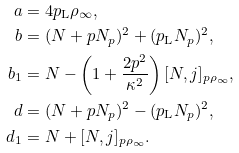Convert formula to latex. <formula><loc_0><loc_0><loc_500><loc_500>a & = 4 p _ { \text {L} } \rho _ { \infty } , \\ b & = ( N + p N _ { p } ) ^ { 2 } + ( p _ { \text {L} } N _ { p } ) ^ { 2 } , \\ b _ { 1 } & = N - \left ( 1 + \frac { 2 p ^ { 2 } } { \kappa ^ { 2 } } \right ) [ N , j ] _ { p \rho _ { \infty } } , \\ d & = ( N + p N _ { p } ) ^ { 2 } - ( p _ { \text {L} } N _ { p } ) ^ { 2 } , \\ d _ { 1 } & = N + [ N , j ] _ { p \rho _ { \infty } } .</formula> 